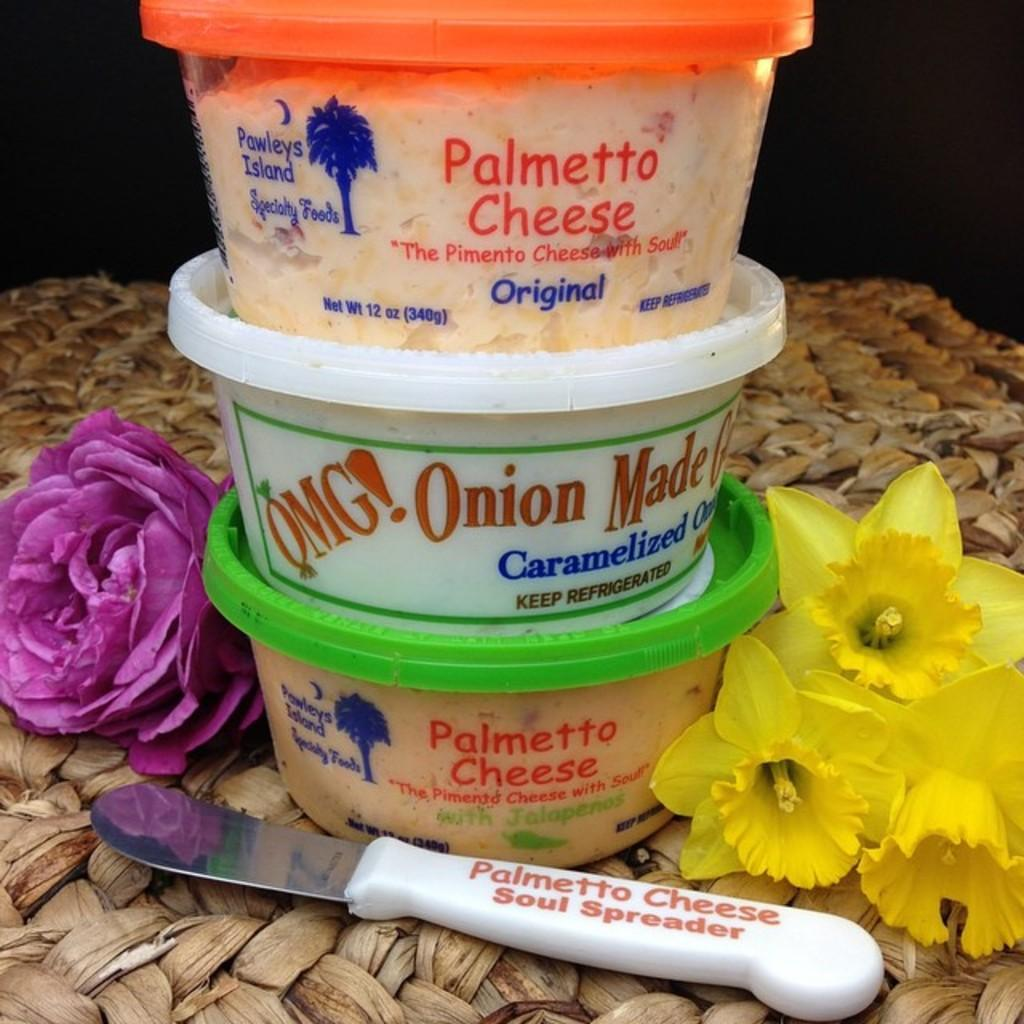<image>
Present a compact description of the photo's key features. a tower of three dips with a cheese spreader labled palmetto cheese 